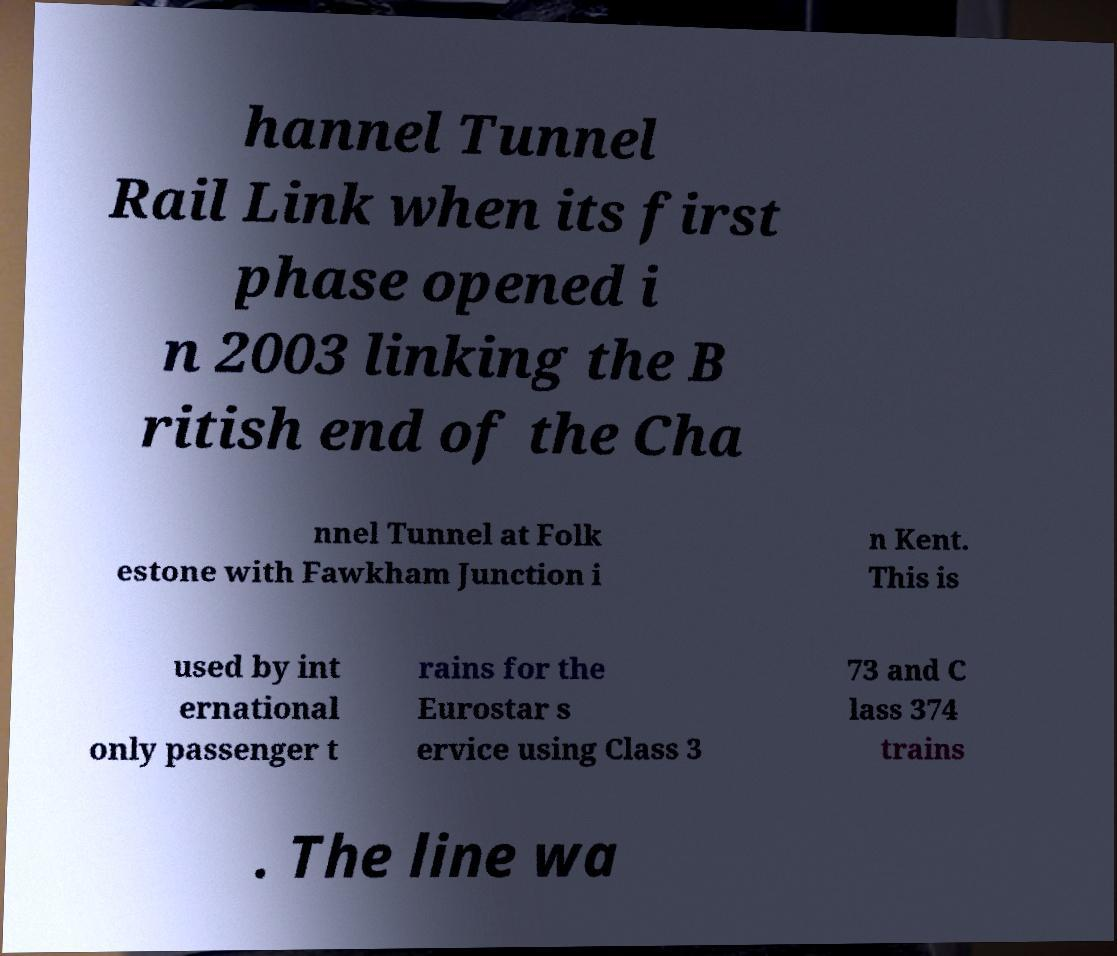There's text embedded in this image that I need extracted. Can you transcribe it verbatim? hannel Tunnel Rail Link when its first phase opened i n 2003 linking the B ritish end of the Cha nnel Tunnel at Folk estone with Fawkham Junction i n Kent. This is used by int ernational only passenger t rains for the Eurostar s ervice using Class 3 73 and C lass 374 trains . The line wa 